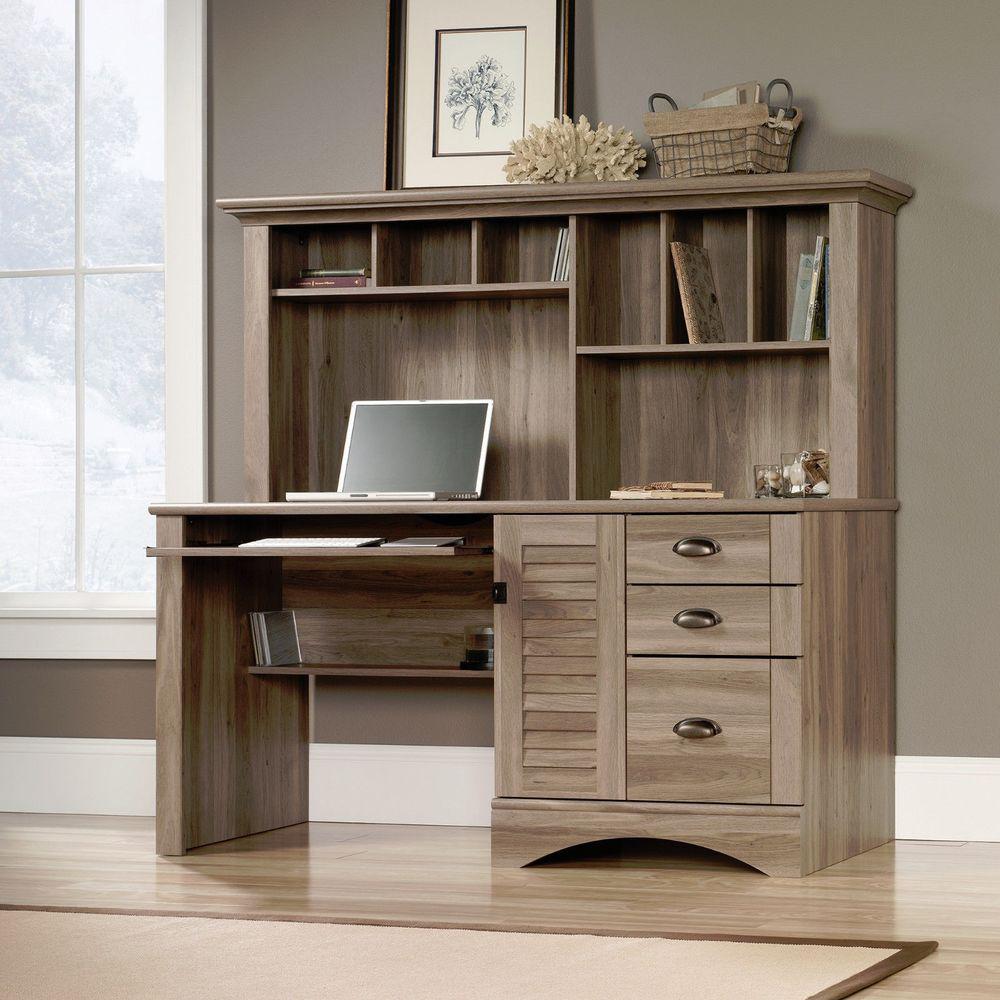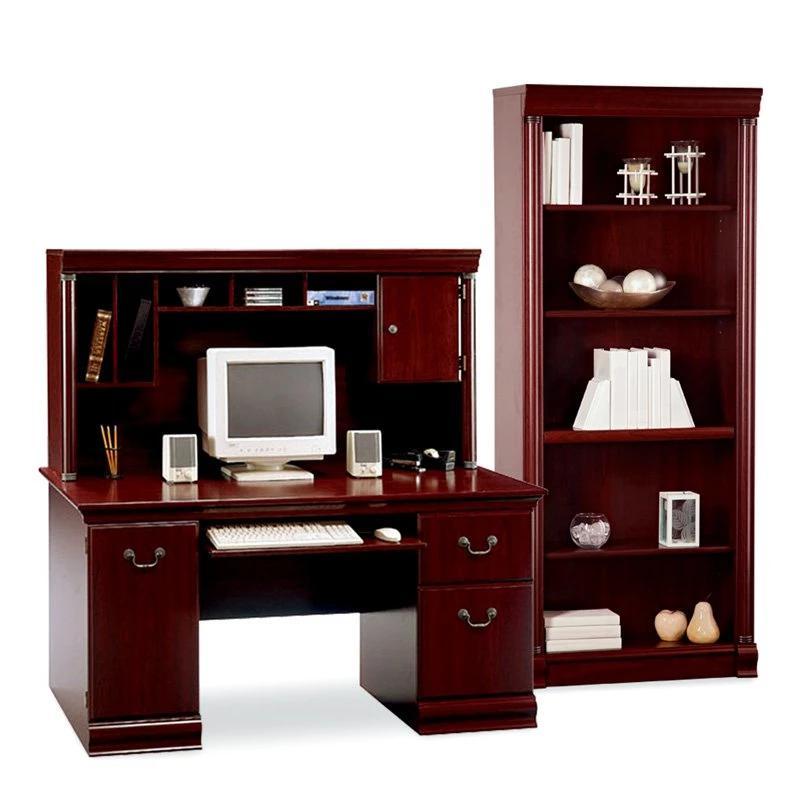The first image is the image on the left, the second image is the image on the right. For the images shown, is this caption "The laptop screen is angled away from the front." true? Answer yes or no. Yes. The first image is the image on the left, the second image is the image on the right. Examine the images to the left and right. Is the description "There is a chair in front of one of the office units." accurate? Answer yes or no. No. 